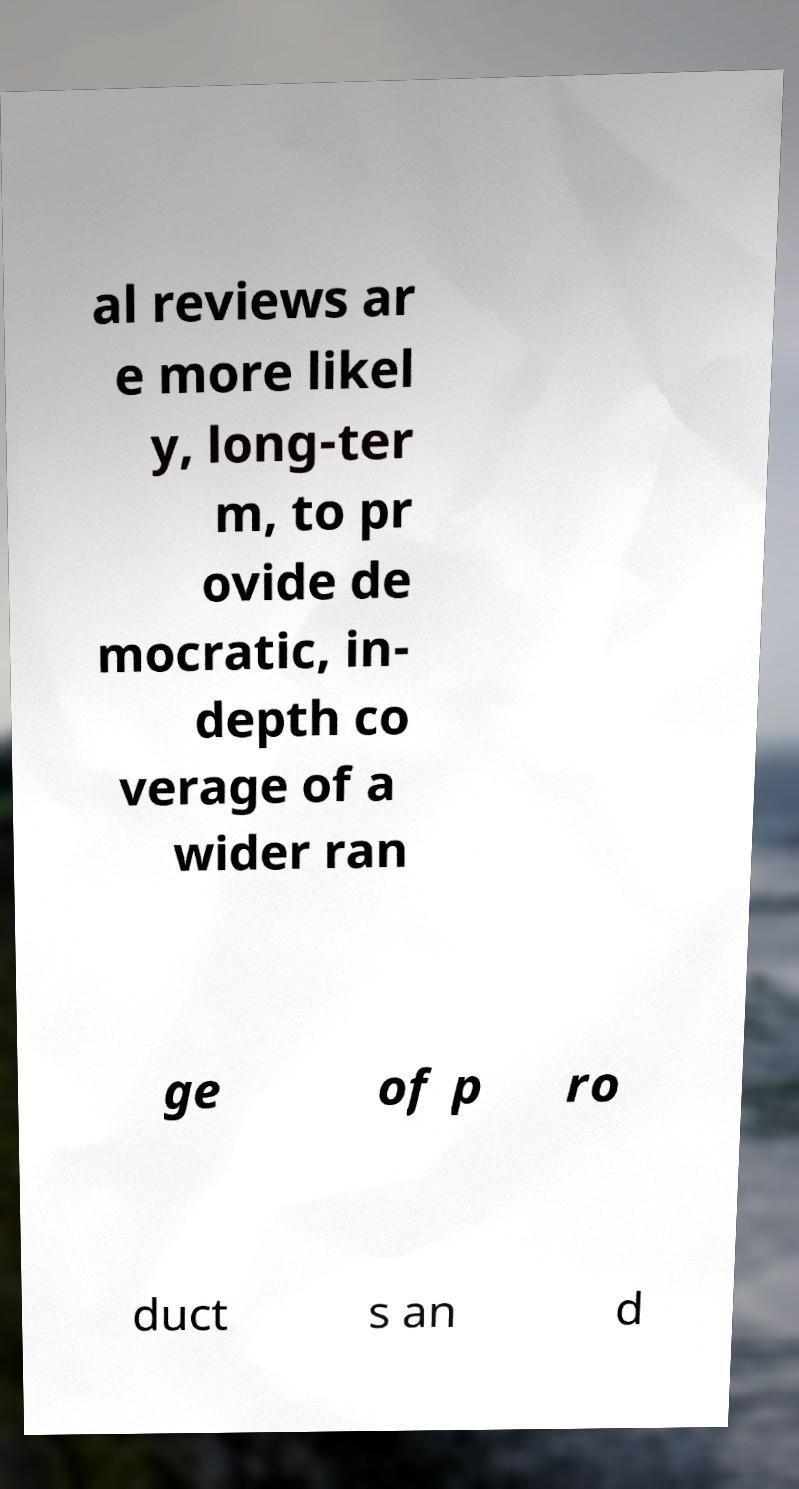Could you extract and type out the text from this image? al reviews ar e more likel y, long-ter m, to pr ovide de mocratic, in- depth co verage of a wider ran ge of p ro duct s an d 